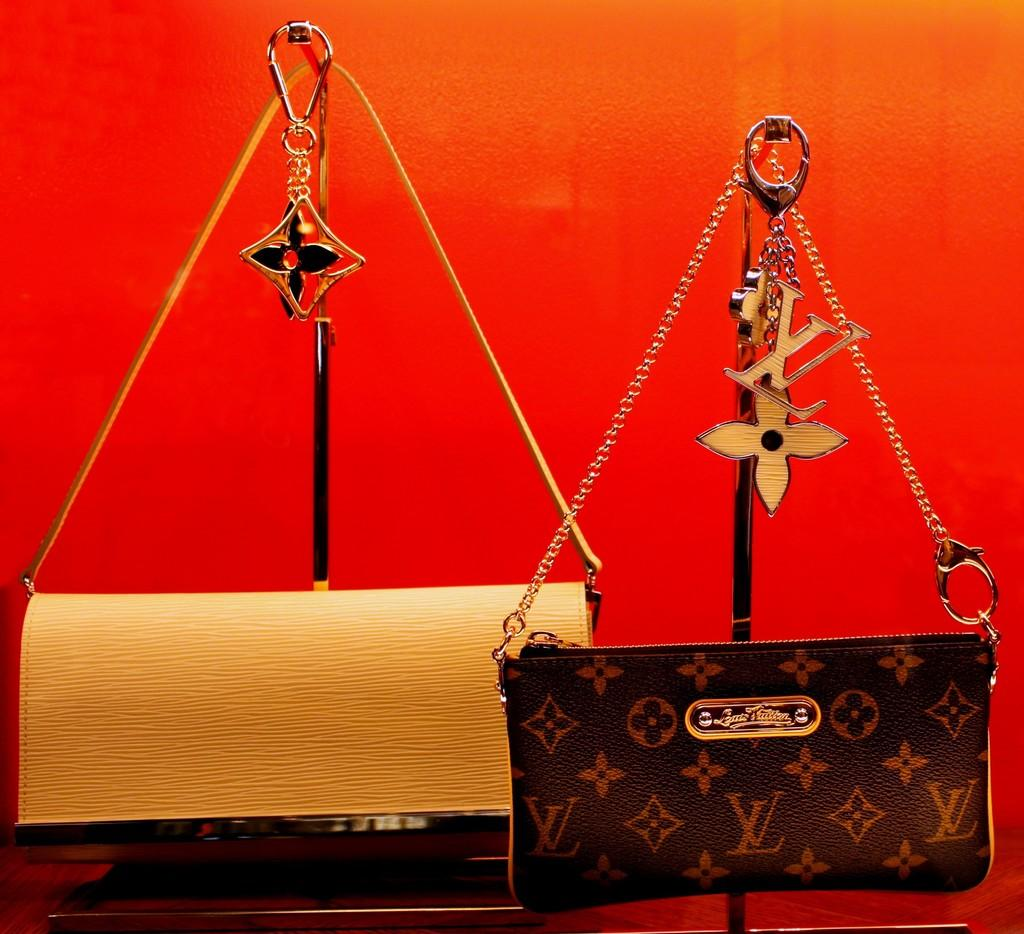How many wallets are visible in the image? There are two wallets in the image. What type of development is the girl working on in the image? There is no girl or development present in the image; it only features two wallets. 